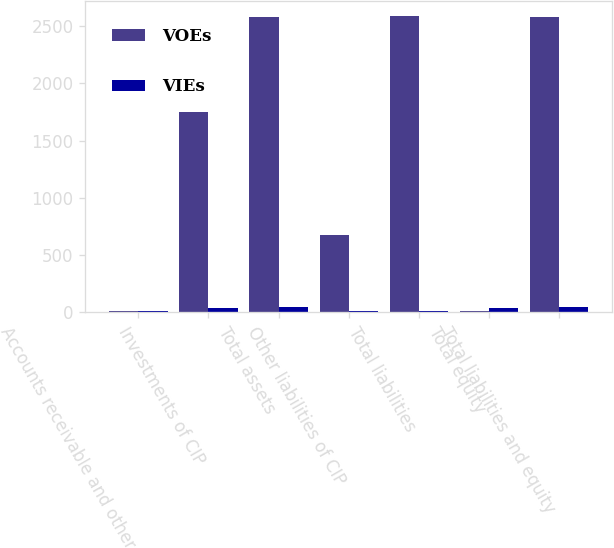Convert chart to OTSL. <chart><loc_0><loc_0><loc_500><loc_500><stacked_bar_chart><ecel><fcel>Accounts receivable and other<fcel>Investments of CIP<fcel>Total assets<fcel>Other liabilities of CIP<fcel>Total liabilities<fcel>Total equity<fcel>Total liabilities and equity<nl><fcel>VOEs<fcel>11.3<fcel>1751.4<fcel>2579.2<fcel>674.7<fcel>2588.4<fcel>9.2<fcel>2579.2<nl><fcel>VIEs<fcel>9<fcel>40.1<fcel>49.1<fcel>11.8<fcel>11.8<fcel>37.3<fcel>49.1<nl></chart> 